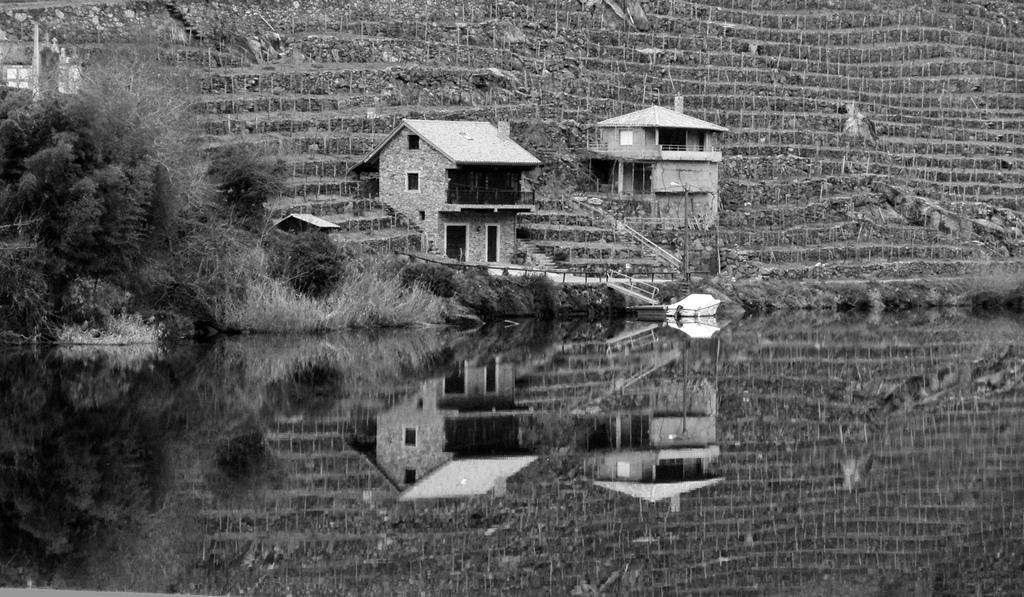What is the color scheme of the image? The image is black and white. What natural feature can be seen in the image? There is a lake in the image. What type of structures are visible in the background? There are houses and a wall in the background of the image. Where are the trees located in the image? The trees are in the top left of the image. How many eggs are rolling down the wall in the image? There are no eggs or rolling motion present in the image. 